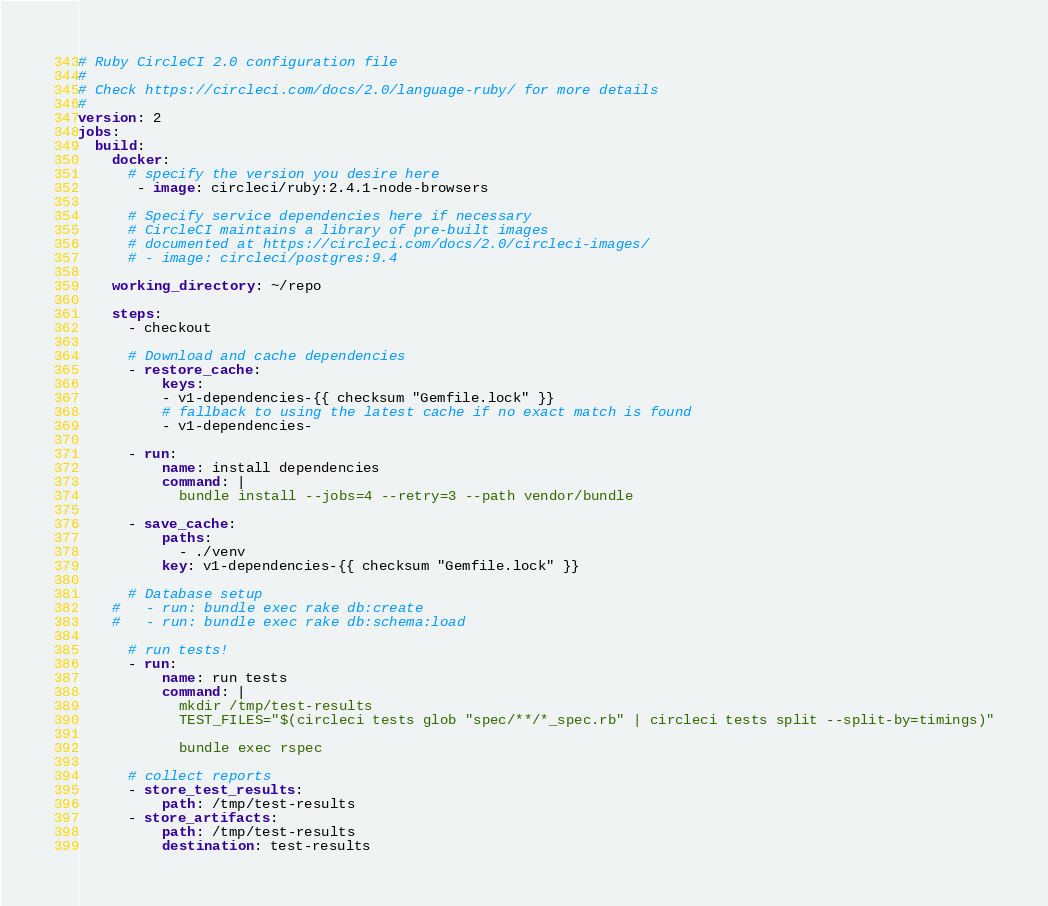<code> <loc_0><loc_0><loc_500><loc_500><_YAML_># Ruby CircleCI 2.0 configuration file
#
# Check https://circleci.com/docs/2.0/language-ruby/ for more details
#
version: 2
jobs:
  build:
    docker:
      # specify the version you desire here
       - image: circleci/ruby:2.4.1-node-browsers
      
      # Specify service dependencies here if necessary
      # CircleCI maintains a library of pre-built images
      # documented at https://circleci.com/docs/2.0/circleci-images/
      # - image: circleci/postgres:9.4

    working_directory: ~/repo

    steps:
      - checkout

      # Download and cache dependencies
      - restore_cache:
          keys:
          - v1-dependencies-{{ checksum "Gemfile.lock" }}
          # fallback to using the latest cache if no exact match is found
          - v1-dependencies-

      - run:
          name: install dependencies
          command: |
            bundle install --jobs=4 --retry=3 --path vendor/bundle

      - save_cache:
          paths:
            - ./venv
          key: v1-dependencies-{{ checksum "Gemfile.lock" }}
        
      # Database setup
    #   - run: bundle exec rake db:create
    #   - run: bundle exec rake db:schema:load

      # run tests!
      - run:
          name: run tests
          command: |
            mkdir /tmp/test-results
            TEST_FILES="$(circleci tests glob "spec/**/*_spec.rb" | circleci tests split --split-by=timings)"
            
            bundle exec rspec 

      # collect reports
      - store_test_results:
          path: /tmp/test-results
      - store_artifacts:
          path: /tmp/test-results
          destination: test-results</code> 